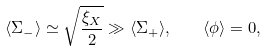<formula> <loc_0><loc_0><loc_500><loc_500>\langle \Sigma _ { - } \rangle \simeq \sqrt { \frac { \xi _ { X } } { 2 } } \gg \langle \Sigma _ { + } \rangle , \quad \langle \phi \rangle = 0 ,</formula> 